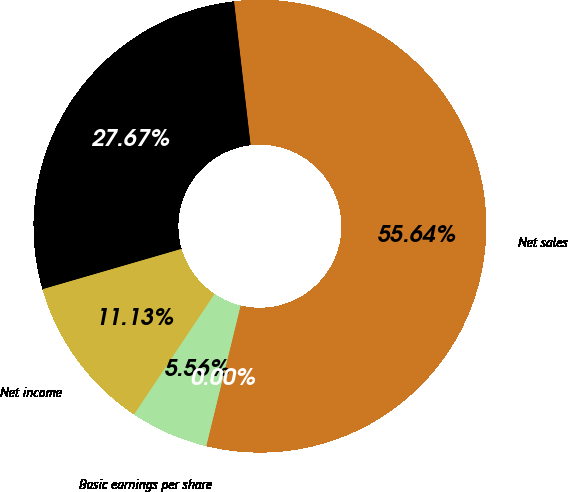Convert chart to OTSL. <chart><loc_0><loc_0><loc_500><loc_500><pie_chart><fcel>Net sales<fcel>Gross profit<fcel>Net income<fcel>Basic earnings per share<fcel>Diluted earnings per share<nl><fcel>55.64%<fcel>27.67%<fcel>11.13%<fcel>5.56%<fcel>0.0%<nl></chart> 